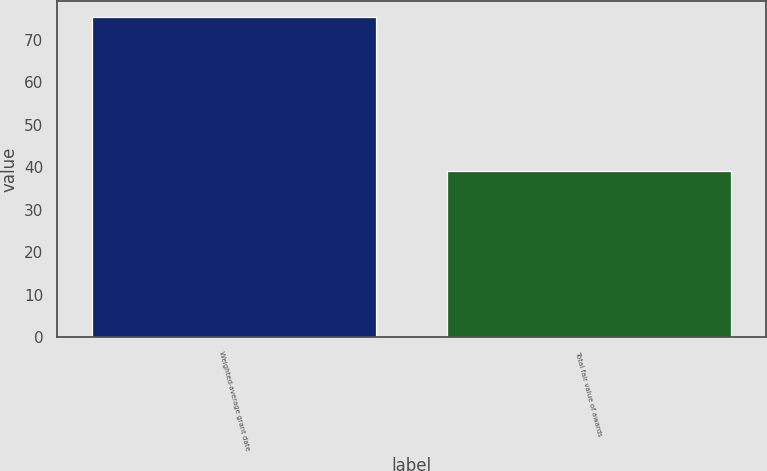<chart> <loc_0><loc_0><loc_500><loc_500><bar_chart><fcel>Weighted-average grant date<fcel>Total fair value of awards<nl><fcel>75.29<fcel>39<nl></chart> 